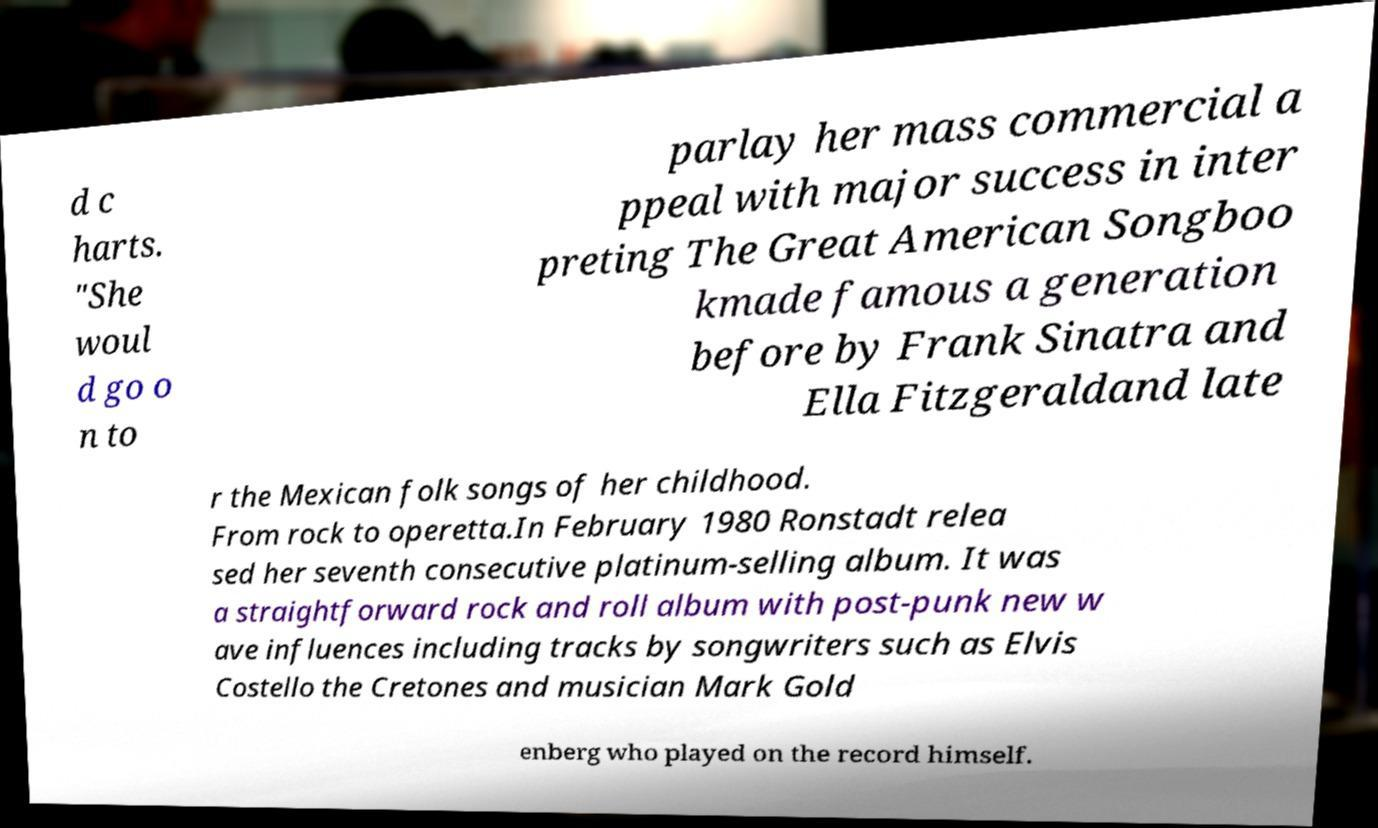Could you assist in decoding the text presented in this image and type it out clearly? d c harts. "She woul d go o n to parlay her mass commercial a ppeal with major success in inter preting The Great American Songboo kmade famous a generation before by Frank Sinatra and Ella Fitzgeraldand late r the Mexican folk songs of her childhood. From rock to operetta.In February 1980 Ronstadt relea sed her seventh consecutive platinum-selling album. It was a straightforward rock and roll album with post-punk new w ave influences including tracks by songwriters such as Elvis Costello the Cretones and musician Mark Gold enberg who played on the record himself. 